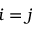<formula> <loc_0><loc_0><loc_500><loc_500>i = j</formula> 